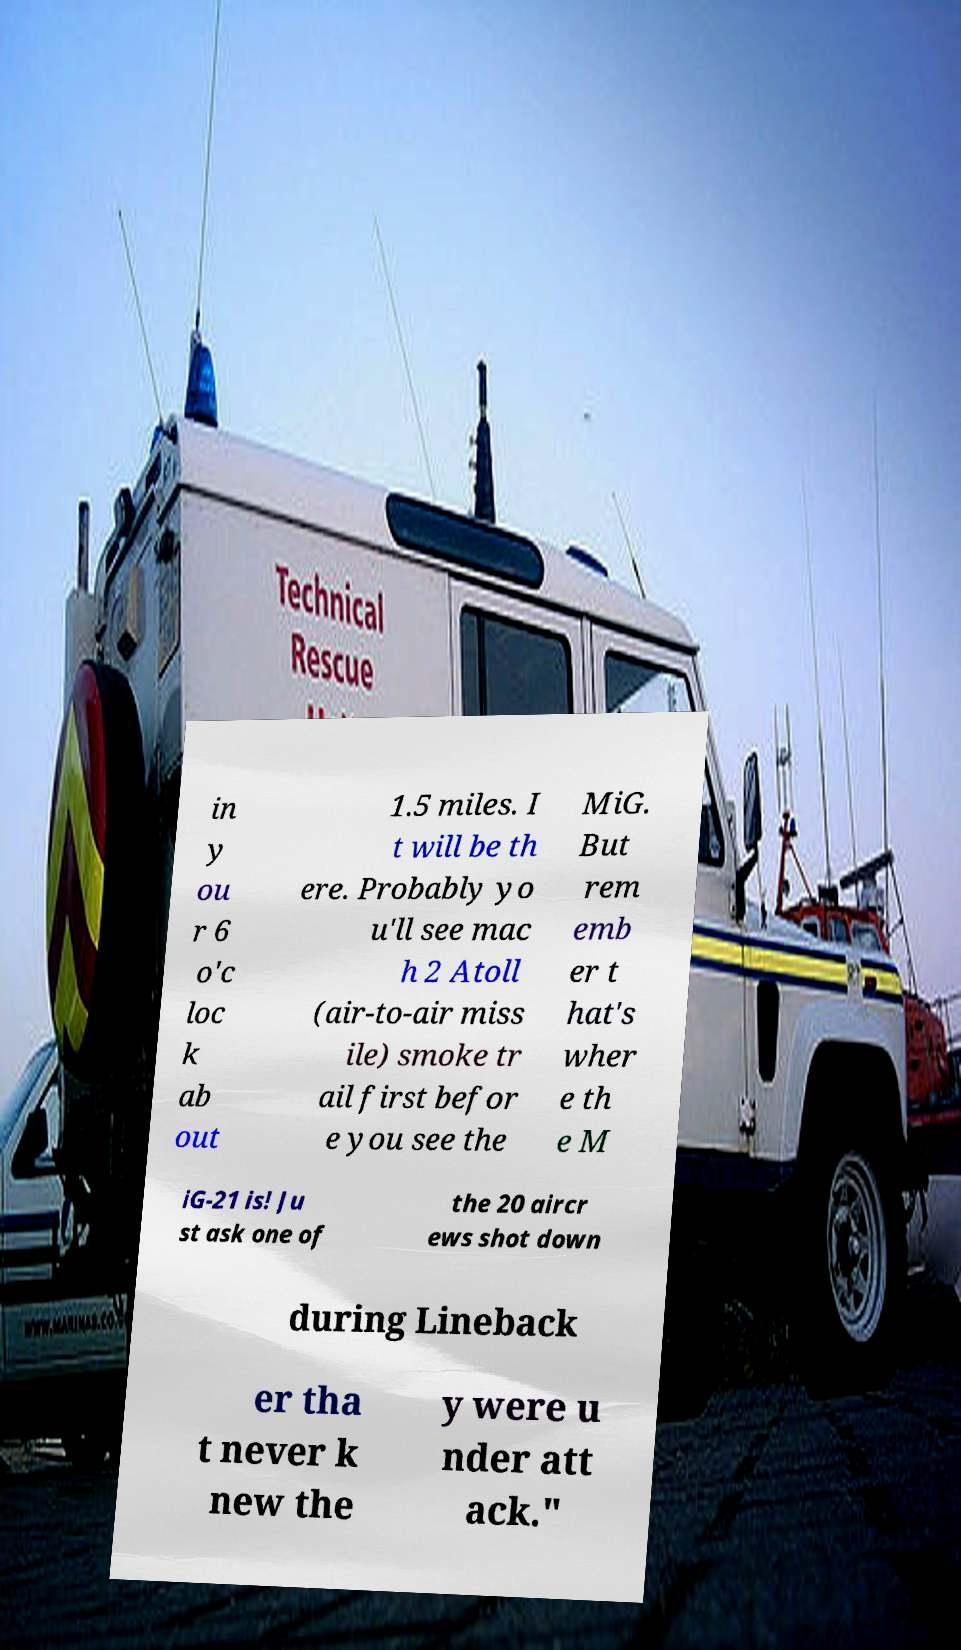For documentation purposes, I need the text within this image transcribed. Could you provide that? in y ou r 6 o'c loc k ab out 1.5 miles. I t will be th ere. Probably yo u'll see mac h 2 Atoll (air-to-air miss ile) smoke tr ail first befor e you see the MiG. But rem emb er t hat's wher e th e M iG-21 is! Ju st ask one of the 20 aircr ews shot down during Lineback er tha t never k new the y were u nder att ack." 